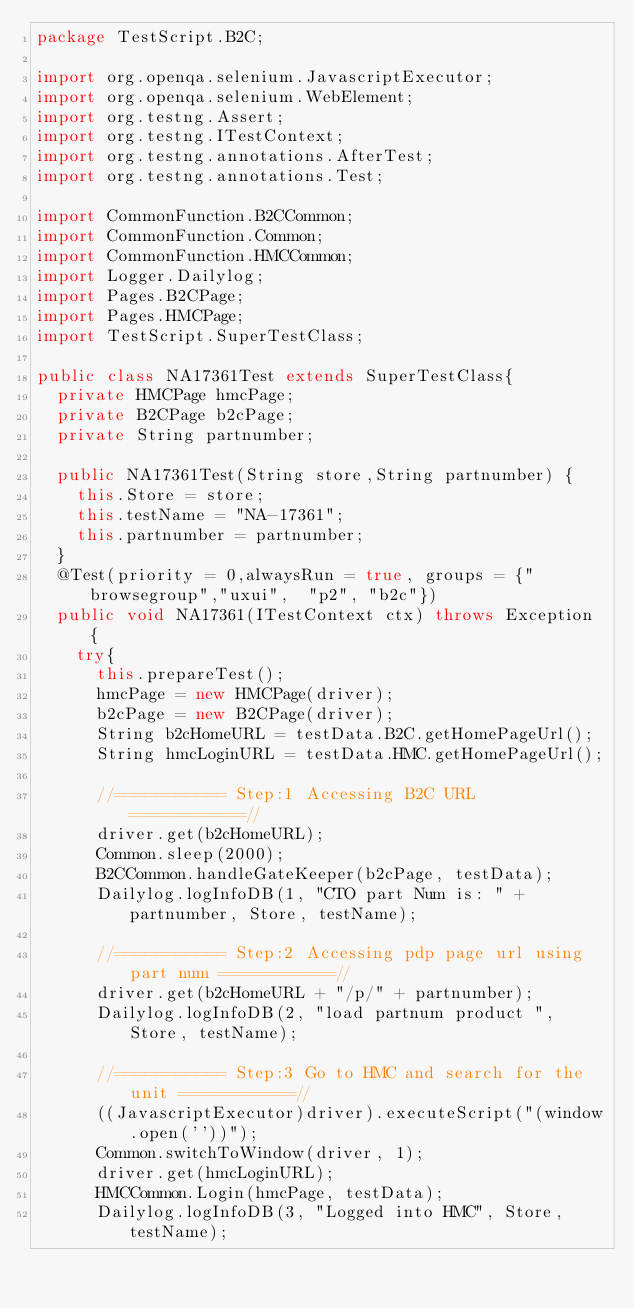<code> <loc_0><loc_0><loc_500><loc_500><_Java_>package TestScript.B2C;

import org.openqa.selenium.JavascriptExecutor;
import org.openqa.selenium.WebElement;
import org.testng.Assert;
import org.testng.ITestContext;
import org.testng.annotations.AfterTest;
import org.testng.annotations.Test;

import CommonFunction.B2CCommon;
import CommonFunction.Common;
import CommonFunction.HMCCommon;
import Logger.Dailylog;
import Pages.B2CPage;
import Pages.HMCPage;
import TestScript.SuperTestClass;

public class NA17361Test extends SuperTestClass{
	private HMCPage hmcPage;
	private B2CPage b2cPage;
	private String partnumber;

	public NA17361Test(String store,String partnumber) {
		this.Store = store;
		this.testName = "NA-17361";
		this.partnumber = partnumber;
	}
	@Test(priority = 0,alwaysRun = true, groups = {"browsegroup","uxui",  "p2", "b2c"})
	public void NA17361(ITestContext ctx) throws Exception {
		try{
			this.prepareTest();
			hmcPage = new HMCPage(driver);
			b2cPage = new B2CPage(driver);
			String b2cHomeURL = testData.B2C.getHomePageUrl();
			String hmcLoginURL = testData.HMC.getHomePageUrl();

			//=========== Step:1 Accessing B2C URL ===========//
			driver.get(b2cHomeURL);
			Common.sleep(2000);
			B2CCommon.handleGateKeeper(b2cPage, testData);
			Dailylog.logInfoDB(1, "CTO part Num is: " + partnumber, Store, testName);

			//=========== Step:2 Accessing pdp page url using part num ===========//
			driver.get(b2cHomeURL + "/p/" + partnumber);
			Dailylog.logInfoDB(2, "load partnum product ", Store, testName);

			//=========== Step:3 Go to HMC and search for the unit ===========//
			((JavascriptExecutor)driver).executeScript("(window.open(''))");
			Common.switchToWindow(driver, 1);
			driver.get(hmcLoginURL);
			HMCCommon.Login(hmcPage, testData);
			Dailylog.logInfoDB(3, "Logged into HMC", Store, testName);</code> 